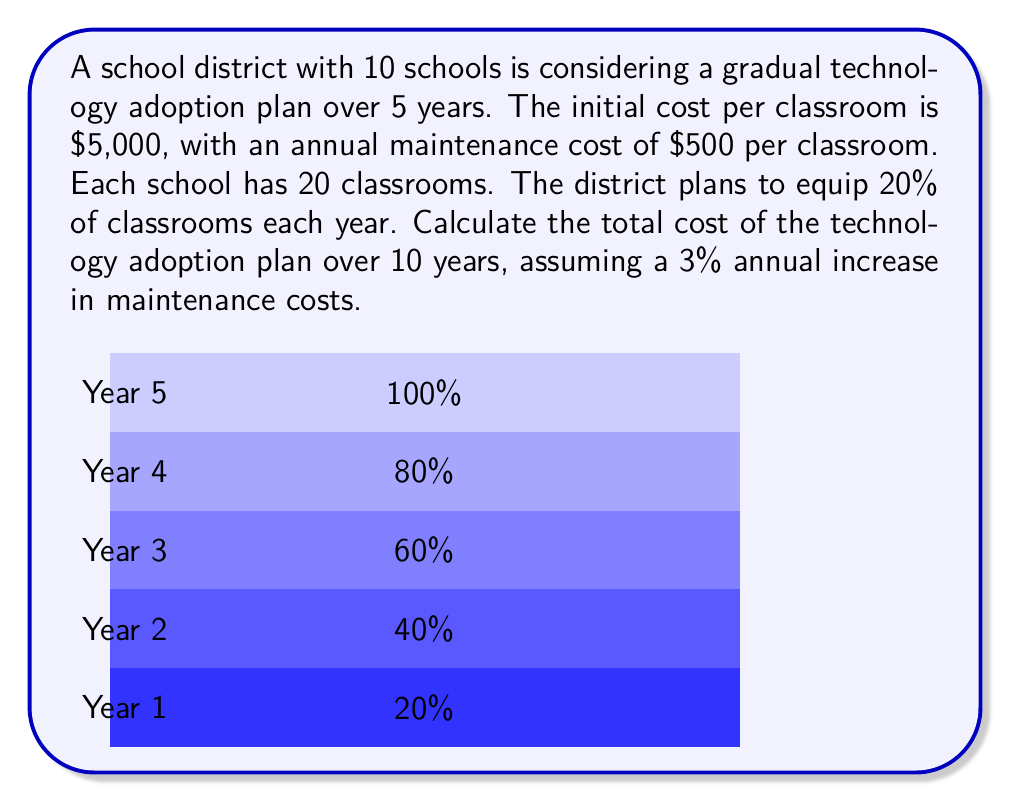Can you answer this question? Let's break this down step-by-step:

1) First, calculate the number of classrooms equipped each year:
   Total classrooms = 10 schools × 20 classrooms = 200 classrooms
   Classrooms equipped per year = 20% of 200 = 40 classrooms

2) Initial equipment costs:
   Cost per year = 40 × $5,000 = $200,000
   Total equipment cost over 5 years = 5 × $200,000 = $1,000,000

3) Maintenance costs:
   Let's calculate this year by year, with a 3% annual increase:

   Year 1: 40 × $500 = $20,000
   Year 2: (40 × $500 × 1.03) + (40 × $500) = $40,600
   Year 3: (80 × $500 × 1.03^2) + (40 × $500) = $62,436
   Year 4: (120 × $500 × 1.03^3) + (40 × $500) = $85,563
   Year 5: (160 × $500 × 1.03^4) + (40 × $500) = $110,037
   Year 6-10: 200 × $500 × 1.03^n, where n = 5, 6, 7, 8, 9

4) Sum of maintenance costs for years 6-10:
   $$\sum_{n=5}^9 200 \times 500 \times 1.03^n = 580,830$$

5) Total maintenance cost:
   $20,000 + $40,600 + $62,436 + $85,563 + $110,037 + $580,830 = $899,466

6) Total cost over 10 years:
   Equipment cost + Total maintenance cost
   $1,000,000 + $899,466 = $1,899,466
Answer: $1,899,466 